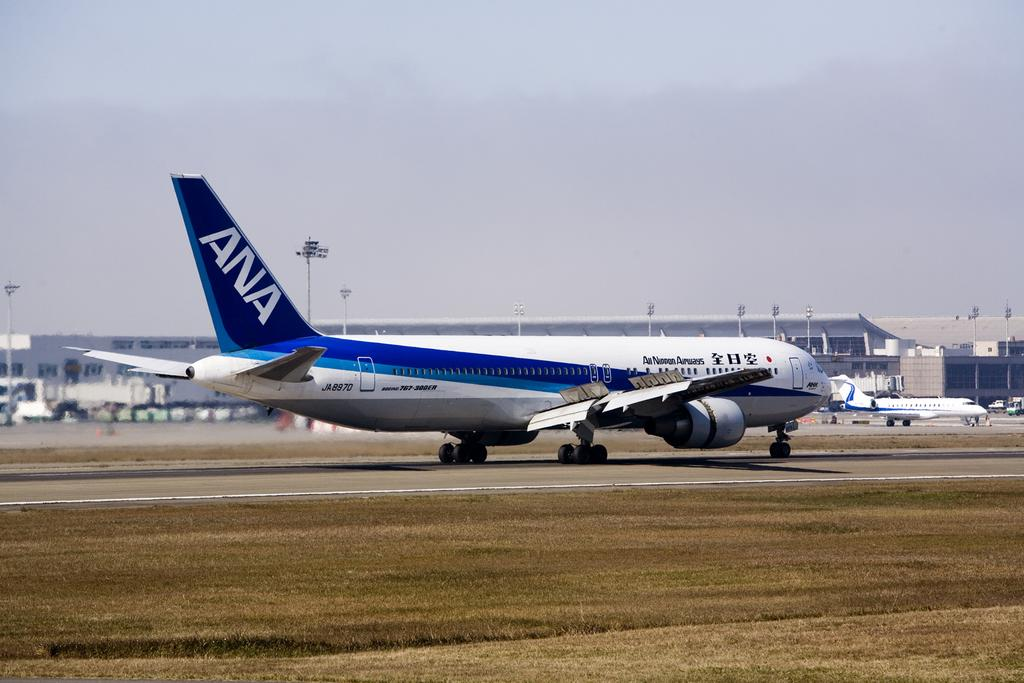What unusual objects can be seen on the road in the image? There are aeroplanes on the road in the image. What can be seen in the distance behind the road? There are buildings in the background of the image. What structures are present alongside the road? There are poles visible in the image. What might be attached to the poles? Lights are visible in the image, which might be attached to the poles. What is visible at the top of the image? The sky is visible at the top of the image. Can you tell me what advice is being given on the receipt in the image? There is no receipt present in the image, so no advice can be found on it. What type of camp can be seen in the image? There is no camp present in the image. 